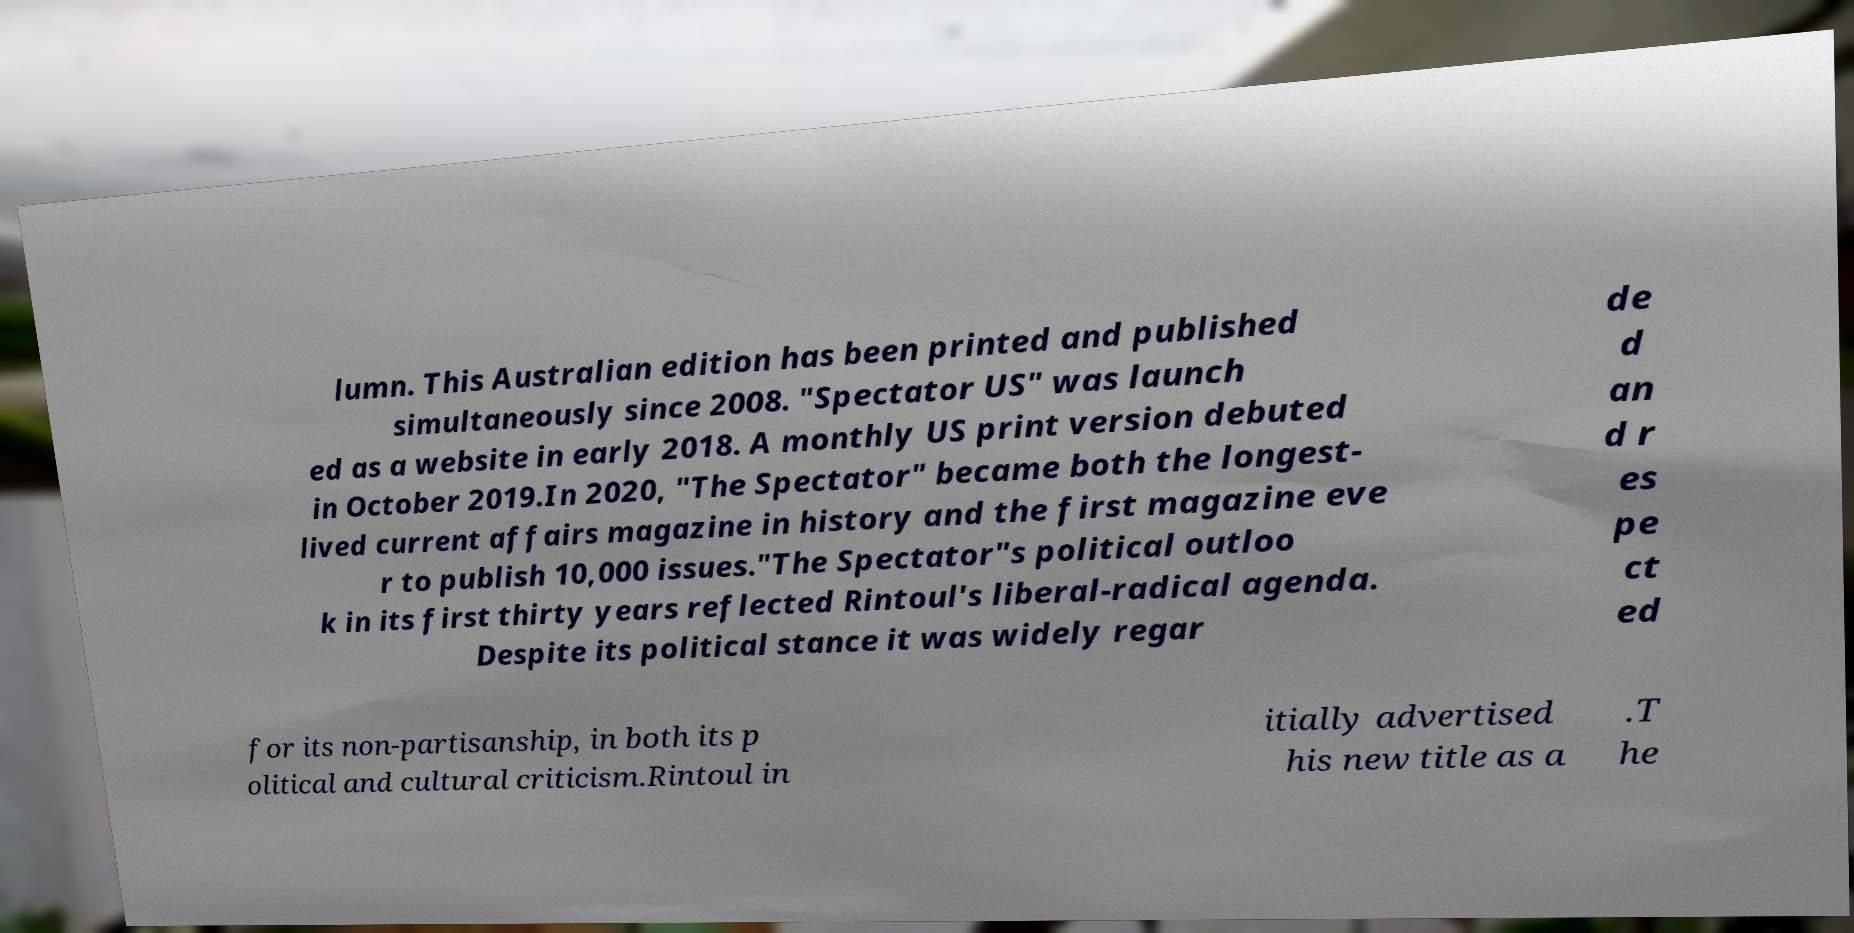There's text embedded in this image that I need extracted. Can you transcribe it verbatim? lumn. This Australian edition has been printed and published simultaneously since 2008. "Spectator US" was launch ed as a website in early 2018. A monthly US print version debuted in October 2019.In 2020, "The Spectator" became both the longest- lived current affairs magazine in history and the first magazine eve r to publish 10,000 issues."The Spectator"s political outloo k in its first thirty years reflected Rintoul's liberal-radical agenda. Despite its political stance it was widely regar de d an d r es pe ct ed for its non-partisanship, in both its p olitical and cultural criticism.Rintoul in itially advertised his new title as a .T he 